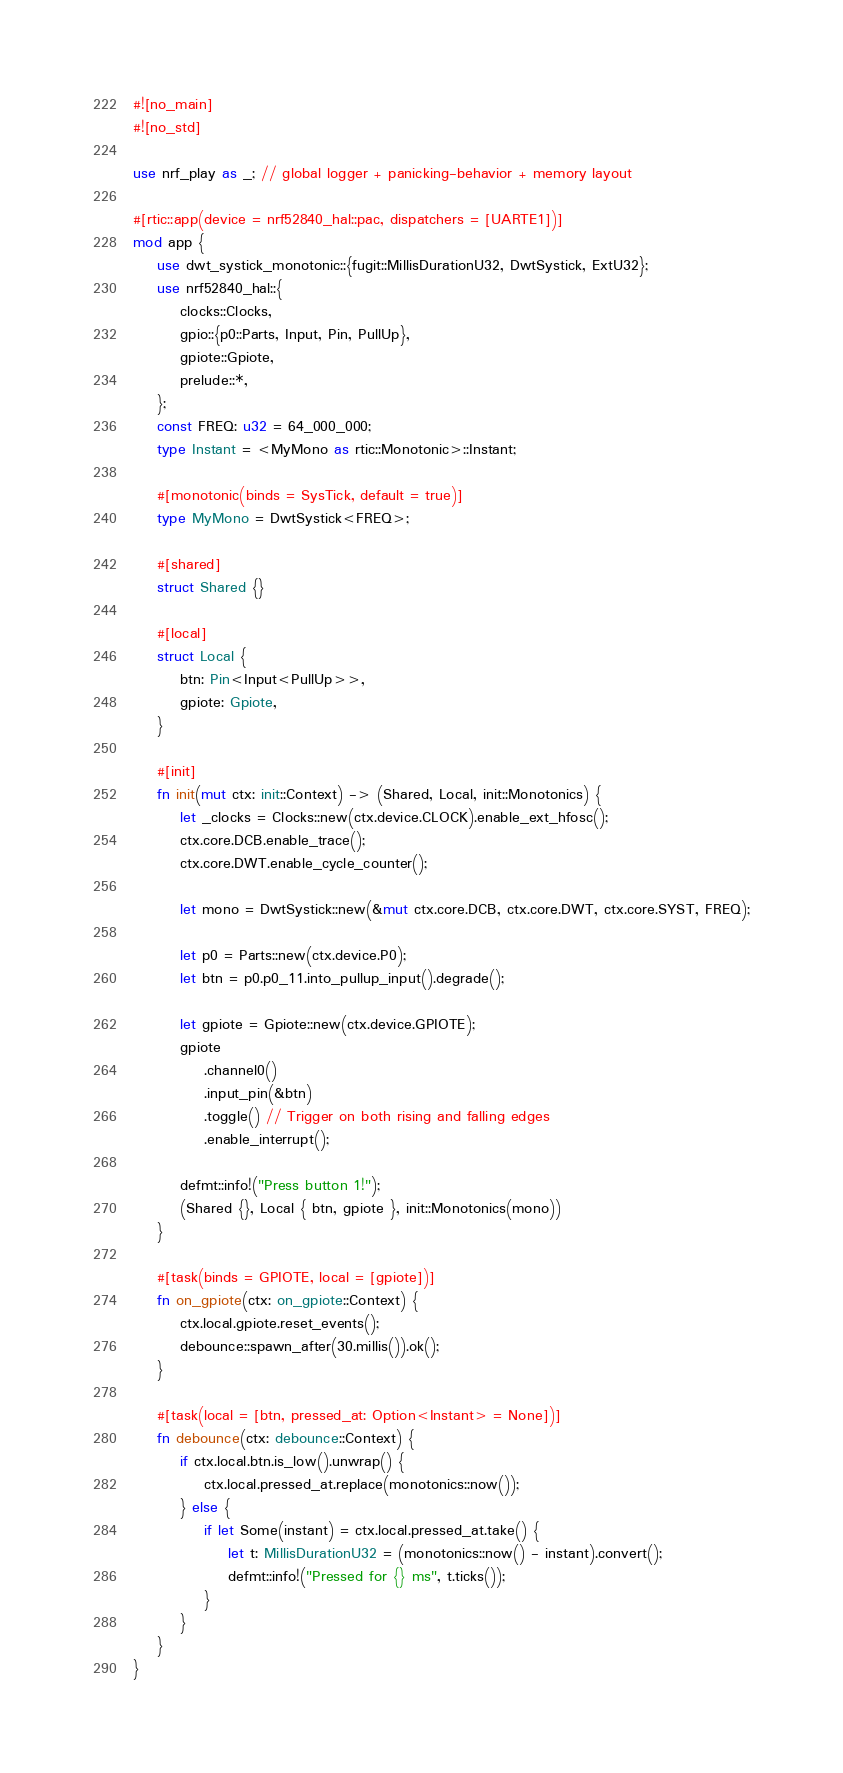Convert code to text. <code><loc_0><loc_0><loc_500><loc_500><_Rust_>#![no_main]
#![no_std]

use nrf_play as _; // global logger + panicking-behavior + memory layout

#[rtic::app(device = nrf52840_hal::pac, dispatchers = [UARTE1])]
mod app {
    use dwt_systick_monotonic::{fugit::MillisDurationU32, DwtSystick, ExtU32};
    use nrf52840_hal::{
        clocks::Clocks,
        gpio::{p0::Parts, Input, Pin, PullUp},
        gpiote::Gpiote,
        prelude::*,
    };
    const FREQ: u32 = 64_000_000;
    type Instant = <MyMono as rtic::Monotonic>::Instant;

    #[monotonic(binds = SysTick, default = true)]
    type MyMono = DwtSystick<FREQ>;

    #[shared]
    struct Shared {}

    #[local]
    struct Local {
        btn: Pin<Input<PullUp>>,
        gpiote: Gpiote,
    }

    #[init]
    fn init(mut ctx: init::Context) -> (Shared, Local, init::Monotonics) {
        let _clocks = Clocks::new(ctx.device.CLOCK).enable_ext_hfosc();
        ctx.core.DCB.enable_trace();
        ctx.core.DWT.enable_cycle_counter();

        let mono = DwtSystick::new(&mut ctx.core.DCB, ctx.core.DWT, ctx.core.SYST, FREQ);

        let p0 = Parts::new(ctx.device.P0);
        let btn = p0.p0_11.into_pullup_input().degrade();

        let gpiote = Gpiote::new(ctx.device.GPIOTE);
        gpiote
            .channel0()
            .input_pin(&btn)
            .toggle() // Trigger on both rising and falling edges
            .enable_interrupt();

        defmt::info!("Press button 1!");
        (Shared {}, Local { btn, gpiote }, init::Monotonics(mono))
    }

    #[task(binds = GPIOTE, local = [gpiote])]
    fn on_gpiote(ctx: on_gpiote::Context) {
        ctx.local.gpiote.reset_events();
        debounce::spawn_after(30.millis()).ok();
    }

    #[task(local = [btn, pressed_at: Option<Instant> = None])]
    fn debounce(ctx: debounce::Context) {
        if ctx.local.btn.is_low().unwrap() {
            ctx.local.pressed_at.replace(monotonics::now());
        } else {
            if let Some(instant) = ctx.local.pressed_at.take() {
                let t: MillisDurationU32 = (monotonics::now() - instant).convert();
                defmt::info!("Pressed for {} ms", t.ticks());
            }
        }
    }
}
</code> 